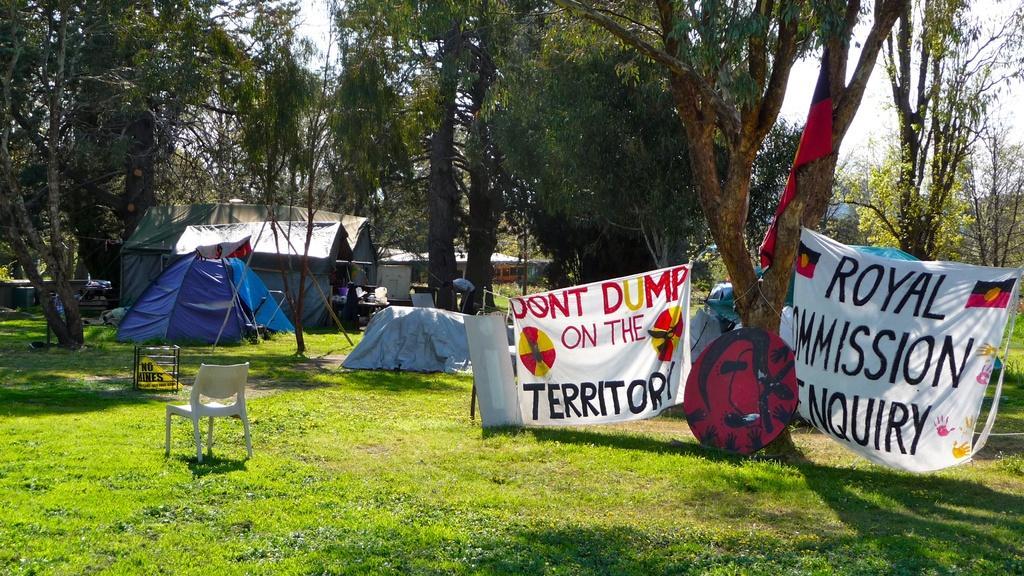In one or two sentences, can you explain what this image depicts? In this picture we can see the view of the park. In front we can see white chair on the grass lawn and behind we can see two blue color canopy tent. On the right corner you can see two white banner on which "Royal Commission Inquiry" is written. In the background we can see some more tents and trees. 